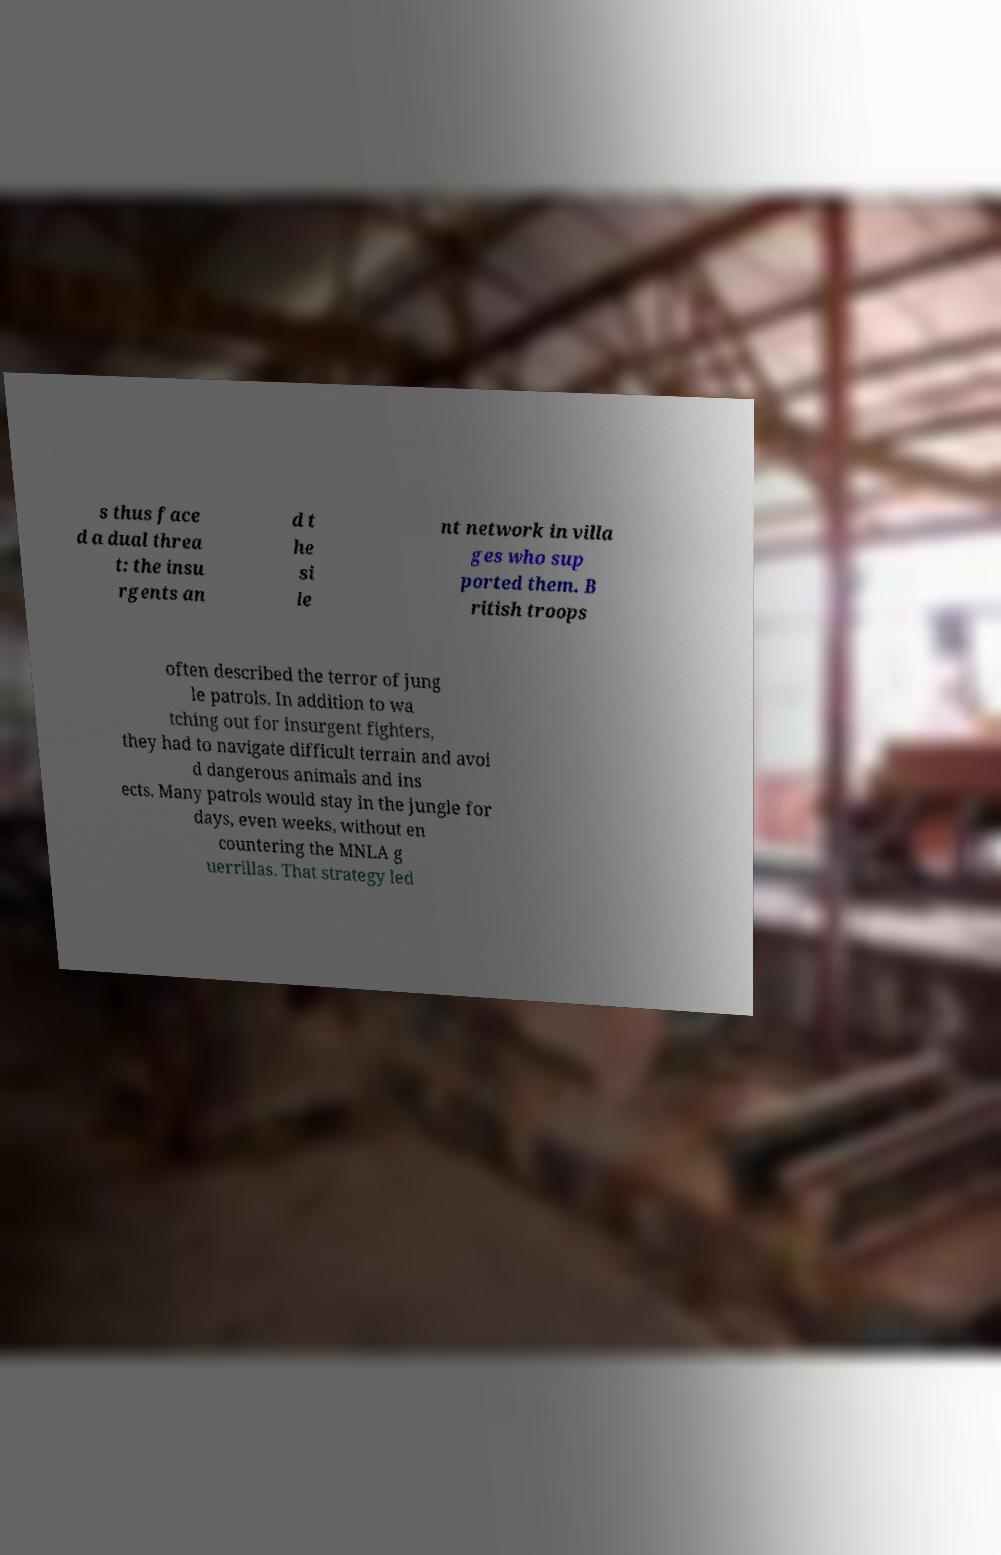Please read and relay the text visible in this image. What does it say? s thus face d a dual threa t: the insu rgents an d t he si le nt network in villa ges who sup ported them. B ritish troops often described the terror of jung le patrols. In addition to wa tching out for insurgent fighters, they had to navigate difficult terrain and avoi d dangerous animals and ins ects. Many patrols would stay in the jungle for days, even weeks, without en countering the MNLA g uerrillas. That strategy led 